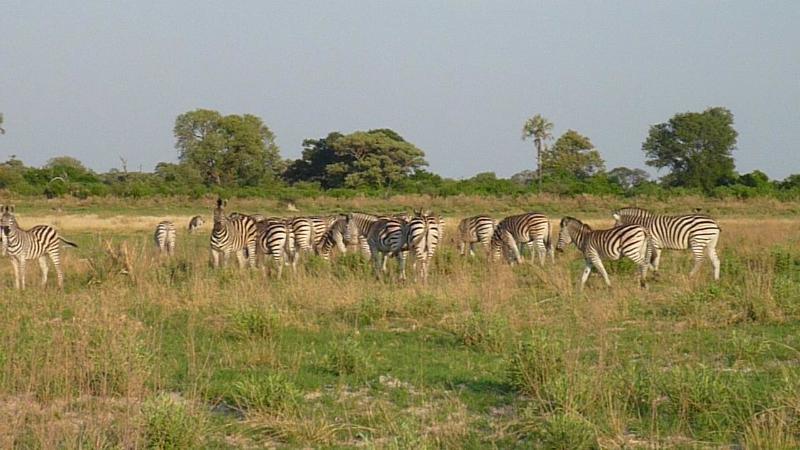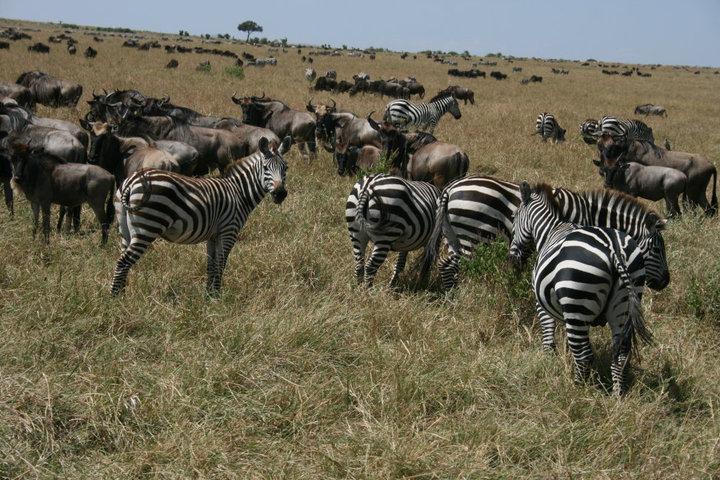The first image is the image on the left, the second image is the image on the right. Assess this claim about the two images: "An image shows several zebras with their backs to the camera facing a group of at least five hooved animals belonging to one other species.". Correct or not? Answer yes or no. Yes. 